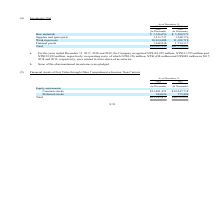According to United Micro Electronics's financial document, What were the operating costs for the year ended December 31, 2017? According to the financial document, NT$118,252 million. The relevant text states: "r 31, 2017, 2018 and 2019, the Company recognized NT$118,252 million, NT$123,795 million and NT$122,999 million, respectively, in operating costs, of which NT$2,256 mil..." Also, How much of operating costs were related to write-down of inventories for year ended December 31, 2017? According to the financial document, NT$2,256 million. The relevant text states: "llion, respectively, in operating costs, of which NT$2,256 million, NT$1,698 million and NT$820 million in 2017, 2018 and 2019, respectively, were related to write-do..." Also, How many inventories were pledged? According to the financial document, None. The relevant text states: "b. None of the aforementioned inventories were pledged...." Also, can you calculate: What was the increase / (decrease) in the raw materials from 2018 to 2019? Based on the calculation: 5,102,571 - 3,766,056, the result is 1336515 (in millions). This is based on the information: "sands) (In Thousands) Raw materials $ 3,766,056 $ 5,102,571 Supplies and spare parts 3,133,737 3,548,376 Work in process 10,034,488 11,309,718 Finished goods 1 NT$ (In Thousands) (In Thousands) Raw ma..." The key data points involved are: 3,766,056, 5,102,571. Also, can you calculate: What was the average Supplies and spare parts? To answer this question, I need to perform calculations using the financial data. The calculation is: (3,133,737 + 3,548,376) / 2, which equals 3341056.5 (in millions). This is based on the information: "56 $ 5,102,571 Supplies and spare parts 3,133,737 3,548,376 Work in process 10,034,488 11,309,718 Finished goods 1,268,838 1,754,137 Total $18,203,119 $21,714, $ 3,766,056 $ 5,102,571 Supplies and spa..." The key data points involved are: 3,133,737, 3,548,376. Also, can you calculate: What was the percentage increase / (decrease) in the Finished goods from 2018 to 2019? To answer this question, I need to perform calculations using the financial data. The calculation is: 1,754,137 / 1,268,838 - 1, which equals 38.25 (percentage). This is based on the information: "ss 10,034,488 11,309,718 Finished goods 1,268,838 1,754,137 Total $18,203,119 $21,714,802 k in process 10,034,488 11,309,718 Finished goods 1,268,838 1,754,137 Total $18,203,119 $21,714,802..." The key data points involved are: 1,268,838, 1,754,137. 